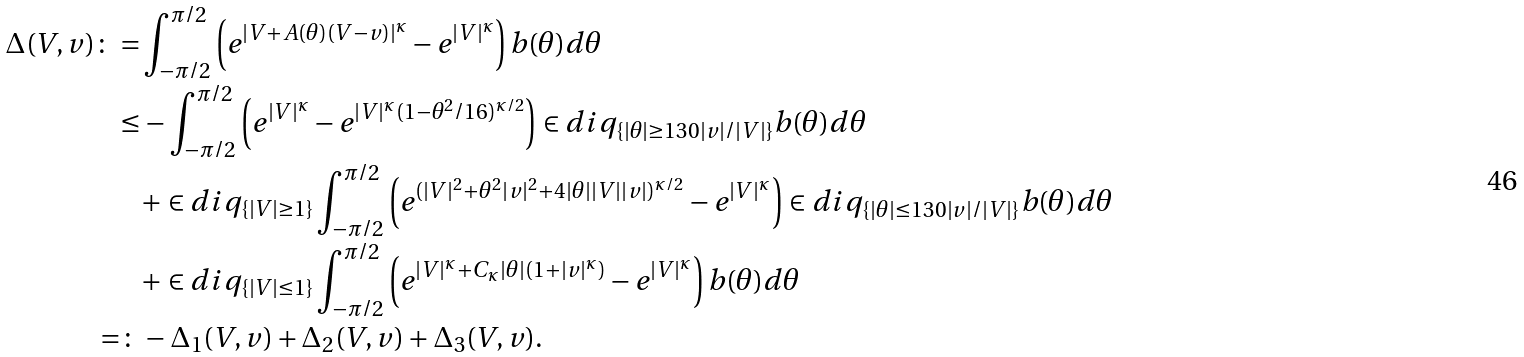Convert formula to latex. <formula><loc_0><loc_0><loc_500><loc_500>\Delta ( V , v ) \colon = & \int _ { - \pi / 2 } ^ { \pi / 2 } \left ( e ^ { | V + A ( \theta ) ( V - v ) | ^ { \kappa } } - e ^ { | V | ^ { \kappa } } \right ) b ( \theta ) d \theta \\ \leq & - \int _ { - \pi / 2 } ^ { \pi / 2 } \left ( e ^ { | V | ^ { \kappa } } - e ^ { | V | ^ { \kappa } ( 1 - \theta ^ { 2 } / 1 6 ) ^ { \kappa / 2 } } \right ) \in d i q _ { \{ | \theta | \geq 1 3 0 | v | / | V | \} } b ( \theta ) d \theta \\ & + \in d i q _ { \{ | V | \geq 1 \} } \int _ { - \pi / 2 } ^ { \pi / 2 } \left ( e ^ { ( | V | ^ { 2 } + \theta ^ { 2 } | v | ^ { 2 } + 4 | \theta | | V | | v | ) ^ { \kappa / 2 } } - e ^ { | V | ^ { \kappa } } \right ) \in d i q _ { \{ | \theta | \leq 1 3 0 | v | / | V | \} } b ( \theta ) d \theta \\ & + \in d i q _ { \{ | V | \leq 1 \} } \int _ { - \pi / 2 } ^ { \pi / 2 } \left ( e ^ { | V | ^ { \kappa } + C _ { \kappa } | \theta | ( 1 + | v | ^ { \kappa } ) } - e ^ { | V | ^ { \kappa } } \right ) b ( \theta ) d \theta \\ = \colon & - \Delta _ { 1 } ( V , v ) + \Delta _ { 2 } ( V , v ) + \Delta _ { 3 } ( V , v ) .</formula> 